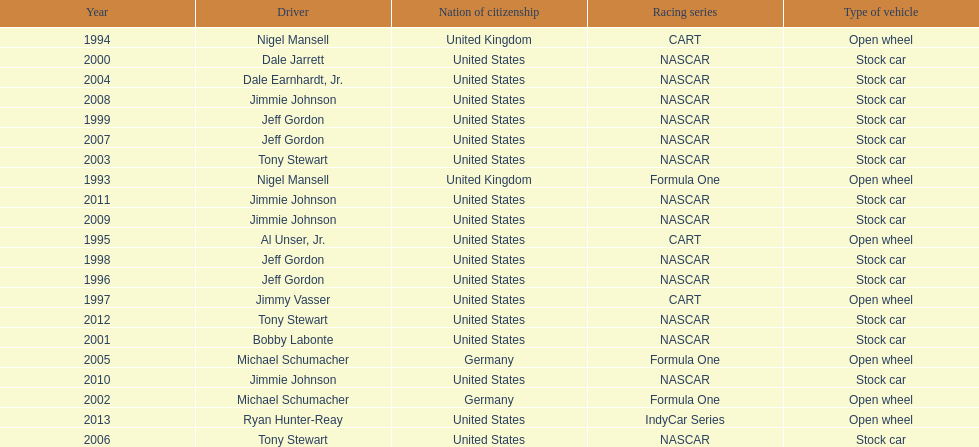Which racing series has the highest total of winners? NASCAR. 